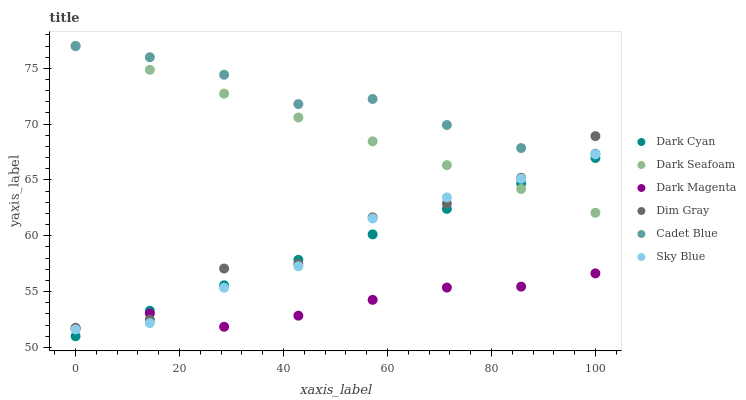Does Dark Magenta have the minimum area under the curve?
Answer yes or no. Yes. Does Cadet Blue have the maximum area under the curve?
Answer yes or no. Yes. Does Dark Seafoam have the minimum area under the curve?
Answer yes or no. No. Does Dark Seafoam have the maximum area under the curve?
Answer yes or no. No. Is Dark Cyan the smoothest?
Answer yes or no. Yes. Is Dim Gray the roughest?
Answer yes or no. Yes. Is Dark Magenta the smoothest?
Answer yes or no. No. Is Dark Magenta the roughest?
Answer yes or no. No. Does Dark Cyan have the lowest value?
Answer yes or no. Yes. Does Dark Magenta have the lowest value?
Answer yes or no. No. Does Cadet Blue have the highest value?
Answer yes or no. Yes. Does Dark Magenta have the highest value?
Answer yes or no. No. Is Dark Cyan less than Cadet Blue?
Answer yes or no. Yes. Is Cadet Blue greater than Sky Blue?
Answer yes or no. Yes. Does Sky Blue intersect Dark Magenta?
Answer yes or no. Yes. Is Sky Blue less than Dark Magenta?
Answer yes or no. No. Is Sky Blue greater than Dark Magenta?
Answer yes or no. No. Does Dark Cyan intersect Cadet Blue?
Answer yes or no. No. 